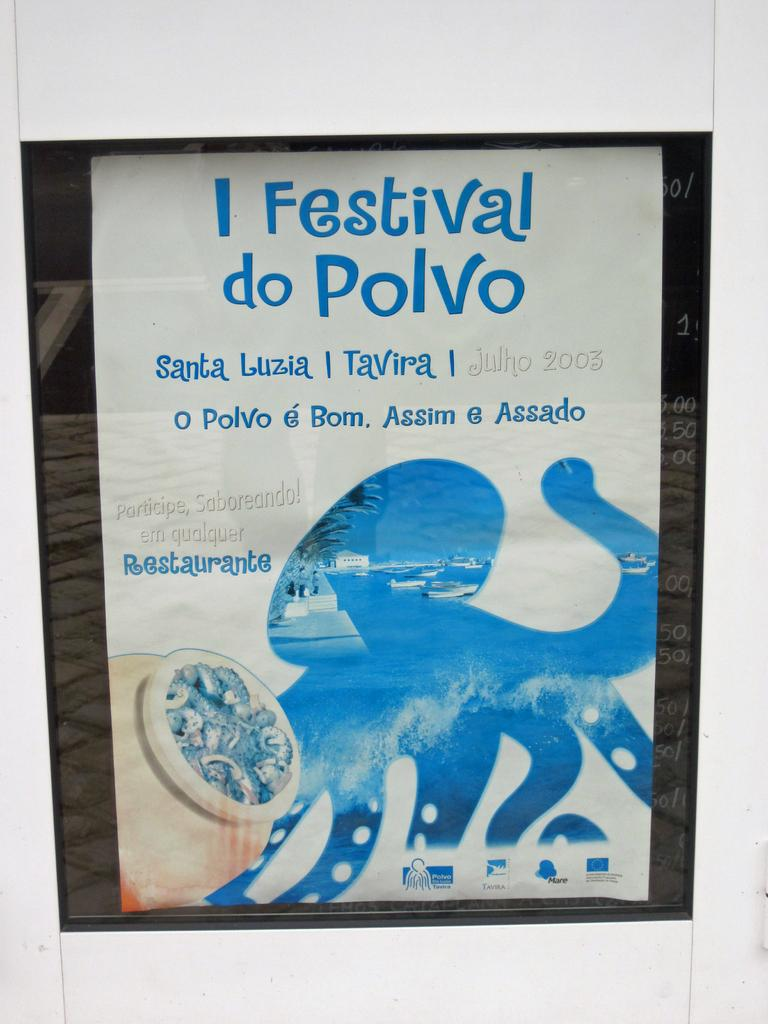<image>
Summarize the visual content of the image. A monkey is on the ad for  festival do polvo. 